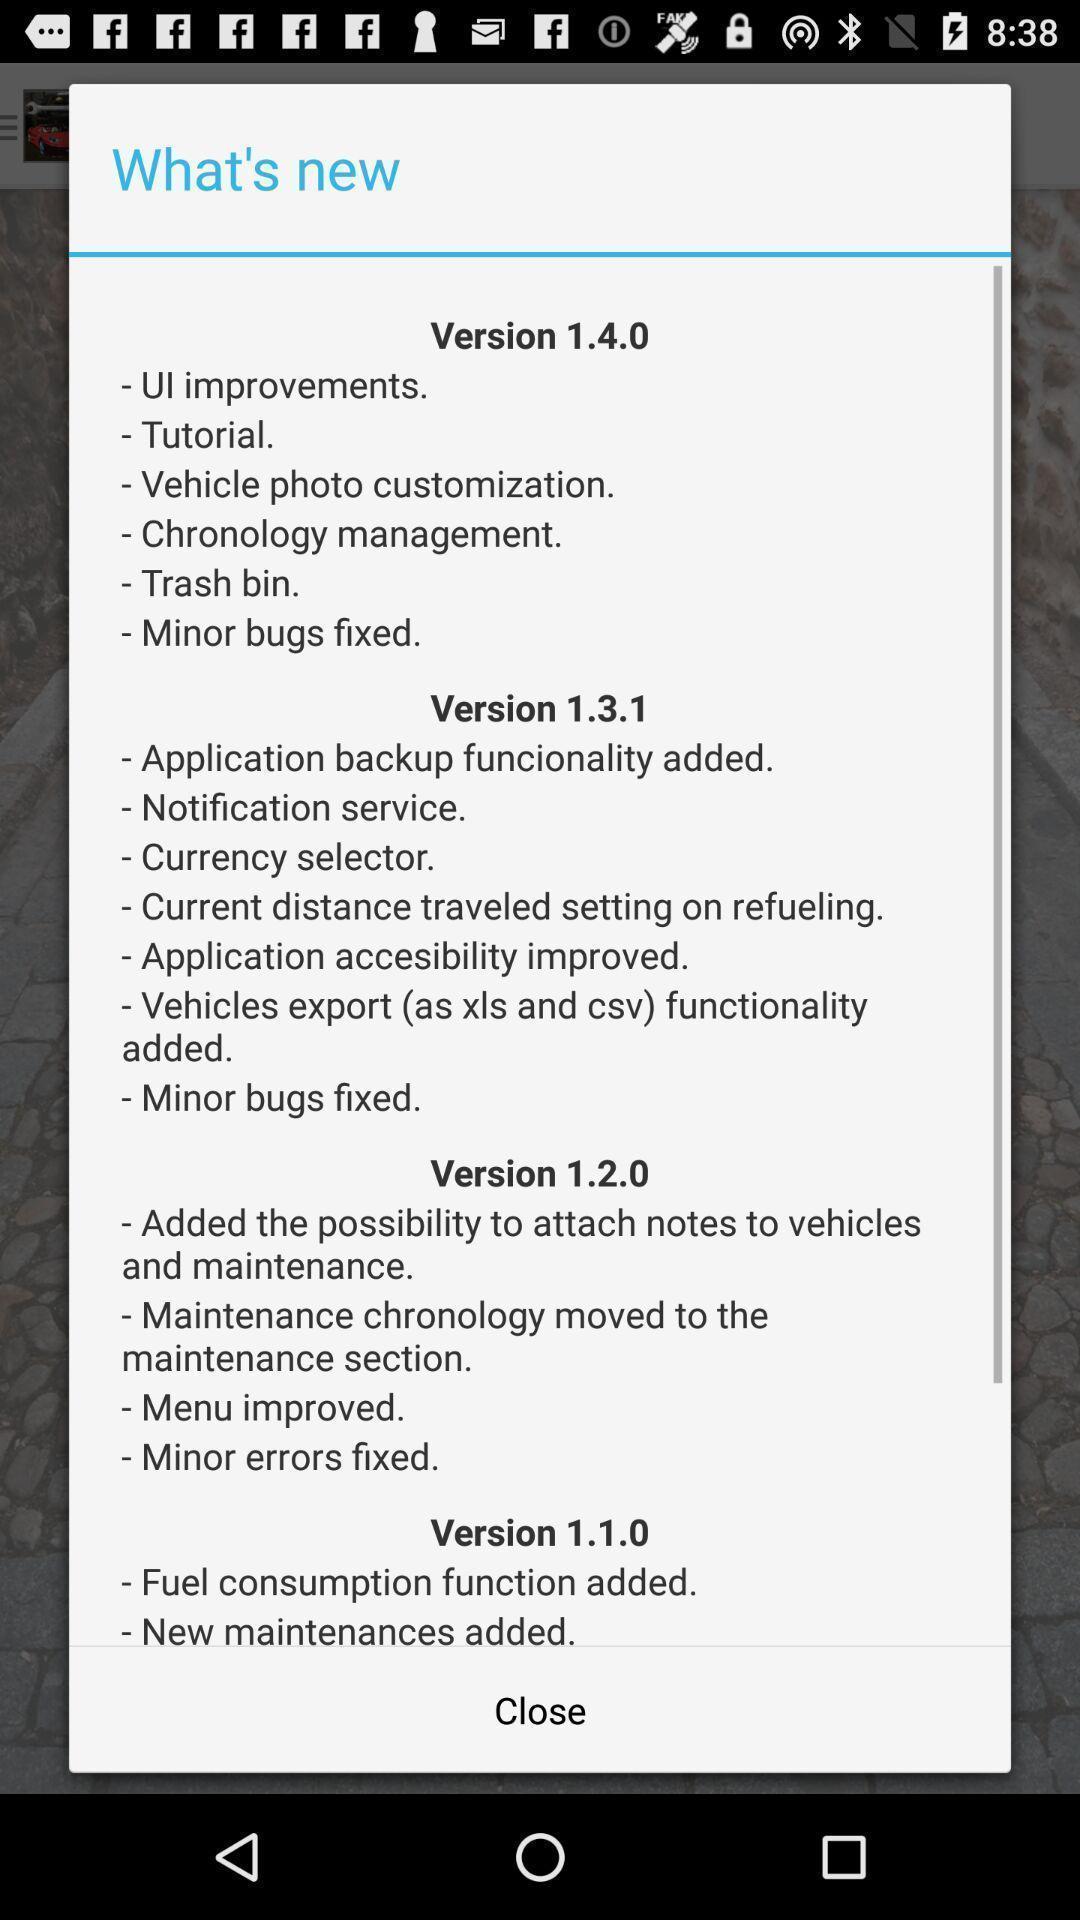What can you discern from this picture? Popup of description regarding new version 's features. 